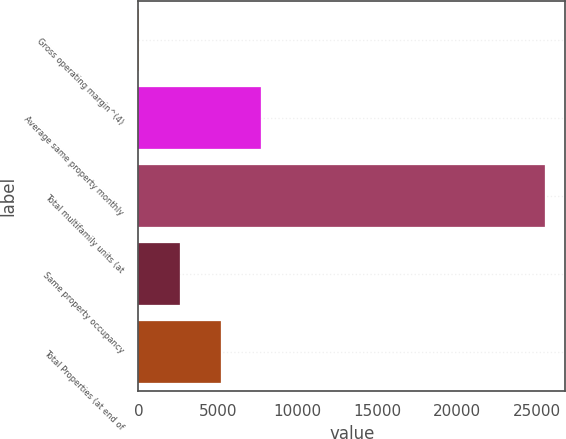Convert chart to OTSL. <chart><loc_0><loc_0><loc_500><loc_500><bar_chart><fcel>Gross operating margin^(4)<fcel>Average same property monthly<fcel>Total multifamily units (at<fcel>Same property occupancy<fcel>Total Properties (at end of<nl><fcel>66<fcel>7701.6<fcel>25518<fcel>2611.2<fcel>5156.4<nl></chart> 